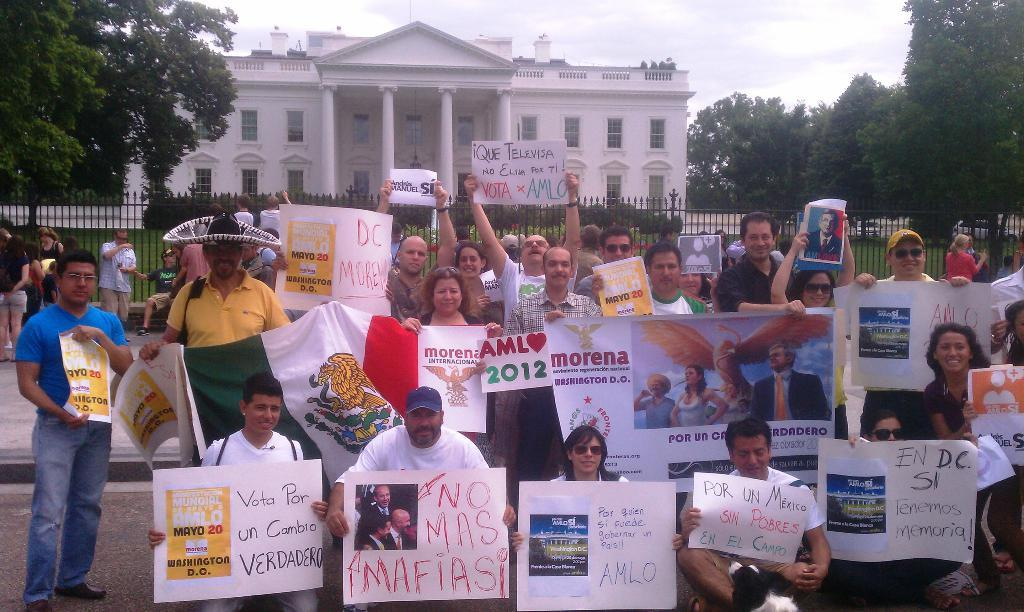What are the people in the image holding? The people in the image are holding posters and a flag. What can be seen in the background of the image? There is a building with windows, trees, plants, and a fence in the background of the image. Where is the lunchroom located in the image? There is no mention of a lunchroom in the image; it features people holding posters and a flag, as well as a background with a building, trees, plants, and a fence. Can you hear a whistle in the image? There is no mention of a whistle in the image; it is a visual representation and does not include sound. 